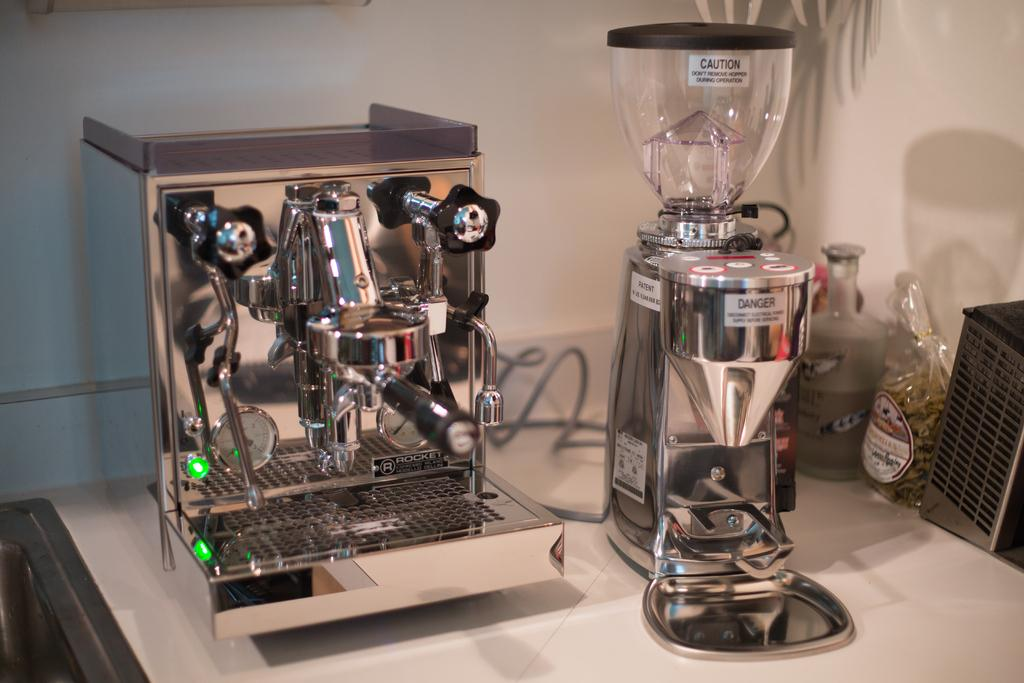<image>
Provide a brief description of the given image. A piece of equipment has a warning sticker about not removing the hopper during operation. 